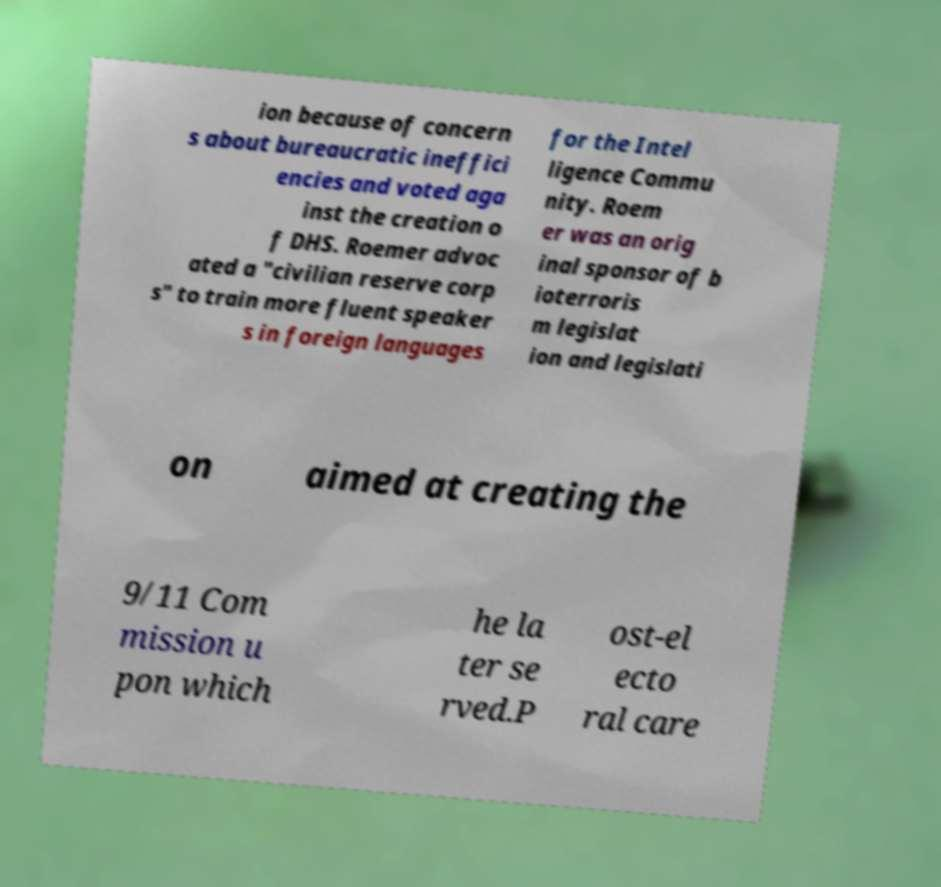There's text embedded in this image that I need extracted. Can you transcribe it verbatim? ion because of concern s about bureaucratic ineffici encies and voted aga inst the creation o f DHS. Roemer advoc ated a "civilian reserve corp s" to train more fluent speaker s in foreign languages for the Intel ligence Commu nity. Roem er was an orig inal sponsor of b ioterroris m legislat ion and legislati on aimed at creating the 9/11 Com mission u pon which he la ter se rved.P ost-el ecto ral care 